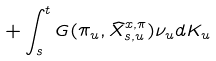Convert formula to latex. <formula><loc_0><loc_0><loc_500><loc_500>+ \int _ { s } ^ { t } G ( \pi _ { u } , \widehat { X } _ { s , u } ^ { x , \pi } ) \nu _ { u } d K _ { u }</formula> 